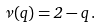<formula> <loc_0><loc_0><loc_500><loc_500>\nu ( q ) = 2 - q \, .</formula> 